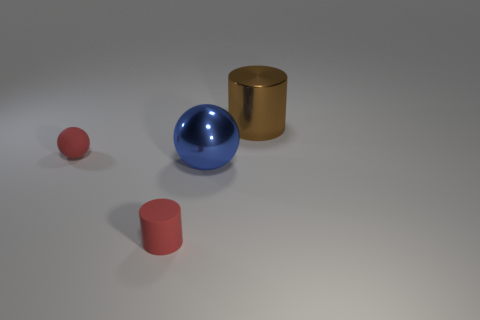Are there an equal number of tiny rubber objects that are on the right side of the tiny matte cylinder and blue balls behind the red ball?
Your answer should be compact. Yes. There is a red rubber thing right of the small red thing behind the large blue metal sphere; what size is it?
Your answer should be very brief. Small. Are there any brown shiny cylinders that have the same size as the red rubber cylinder?
Make the answer very short. No. There is another object that is the same material as the blue thing; what color is it?
Your response must be concise. Brown. Is the number of red cylinders less than the number of tiny brown cubes?
Your response must be concise. No. The object that is both to the right of the rubber cylinder and behind the big shiny ball is made of what material?
Offer a terse response. Metal. Is there a blue metallic sphere in front of the big shiny thing that is to the left of the large brown thing?
Provide a short and direct response. No. What number of big objects have the same color as the large sphere?
Your response must be concise. 0. There is a small sphere that is the same color as the rubber cylinder; what is its material?
Offer a very short reply. Rubber. Is the material of the big ball the same as the large cylinder?
Your answer should be very brief. Yes. 